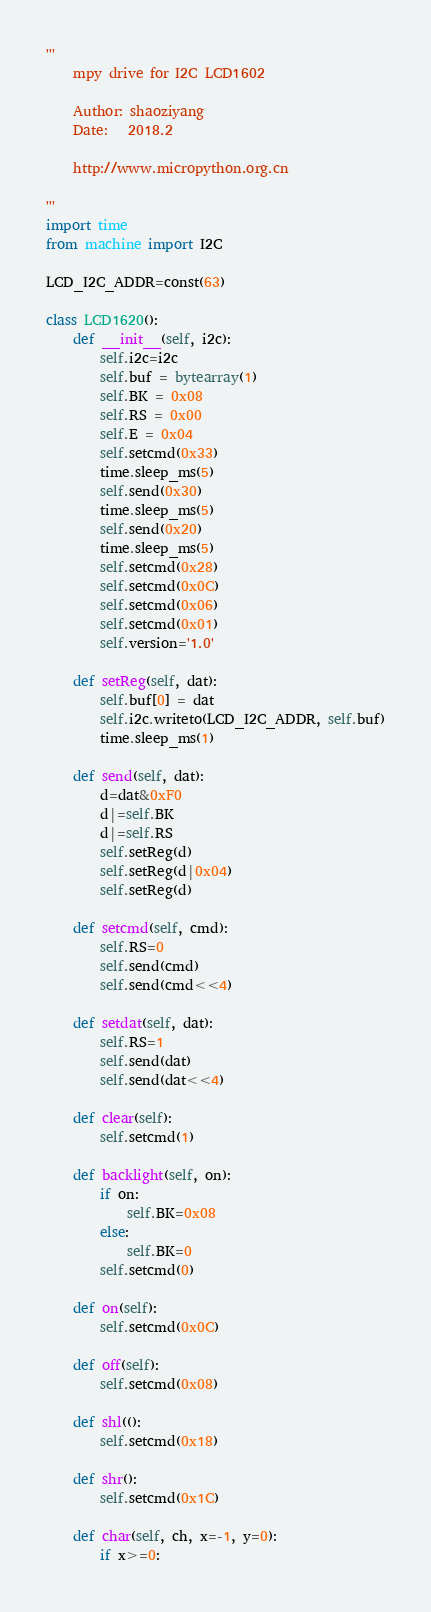<code> <loc_0><loc_0><loc_500><loc_500><_Python_>'''
    mpy drive for I2C LCD1602

    Author: shaoziyang
    Date:   2018.2

    http://www.micropython.org.cn

'''
import time
from machine import I2C

LCD_I2C_ADDR=const(63)

class LCD1620():
    def __init__(self, i2c):
        self.i2c=i2c
        self.buf = bytearray(1)
        self.BK = 0x08
        self.RS = 0x00
        self.E = 0x04
        self.setcmd(0x33)
        time.sleep_ms(5)
        self.send(0x30)
        time.sleep_ms(5)
        self.send(0x20)
        time.sleep_ms(5)
        self.setcmd(0x28)
        self.setcmd(0x0C)
        self.setcmd(0x06)
        self.setcmd(0x01)
        self.version='1.0'

    def setReg(self, dat):
        self.buf[0] = dat
        self.i2c.writeto(LCD_I2C_ADDR, self.buf)
        time.sleep_ms(1)

    def send(self, dat):
        d=dat&0xF0
        d|=self.BK
        d|=self.RS
        self.setReg(d)
        self.setReg(d|0x04)
        self.setReg(d)

    def setcmd(self, cmd):
        self.RS=0
        self.send(cmd)
        self.send(cmd<<4)

    def setdat(self, dat):
        self.RS=1
        self.send(dat)
        self.send(dat<<4)

    def clear(self):
        self.setcmd(1)

    def backlight(self, on):
        if on:
            self.BK=0x08
        else:
            self.BK=0
        self.setcmd(0)

    def on(self):
        self.setcmd(0x0C)

    def off(self):
        self.setcmd(0x08)

    def shl(():
        self.setcmd(0x18)

    def shr():
        self.setcmd(0x1C)

    def char(self, ch, x=-1, y=0):
        if x>=0:</code> 